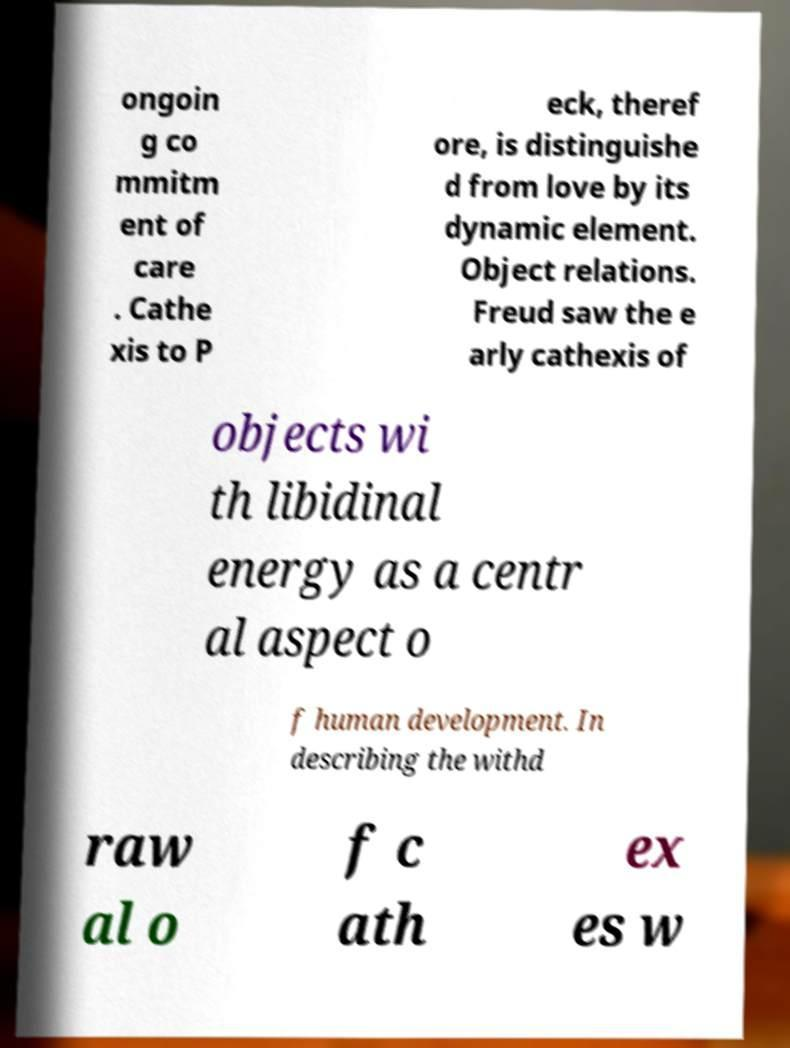I need the written content from this picture converted into text. Can you do that? ongoin g co mmitm ent of care . Cathe xis to P eck, theref ore, is distinguishe d from love by its dynamic element. Object relations. Freud saw the e arly cathexis of objects wi th libidinal energy as a centr al aspect o f human development. In describing the withd raw al o f c ath ex es w 